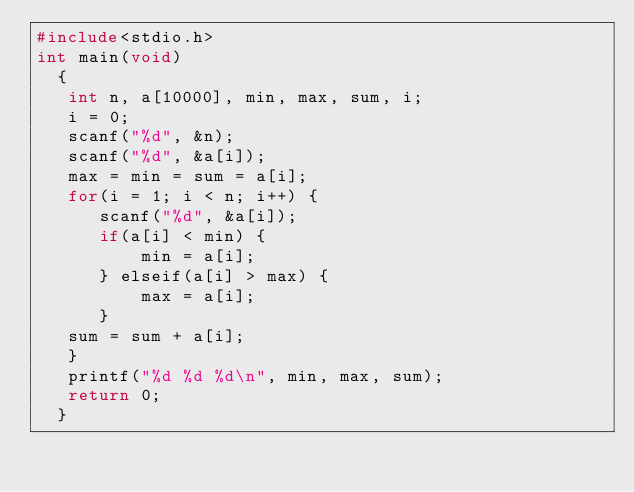Convert code to text. <code><loc_0><loc_0><loc_500><loc_500><_C_>#include<stdio.h>
int main(void)
  {
   int n, a[10000], min, max, sum, i;
   i = 0;
   scanf("%d", &n);
   scanf("%d", &a[i]);
   max = min = sum = a[i];
   for(i = 1; i < n; i++) {
      scanf("%d", &a[i]);
      if(a[i] < min) {
          min = a[i];
      } elseif(a[i] > max) {
          max = a[i];
      }
   sum = sum + a[i];
   }
   printf("%d %d %d\n", min, max, sum);
   return 0;
  }</code> 